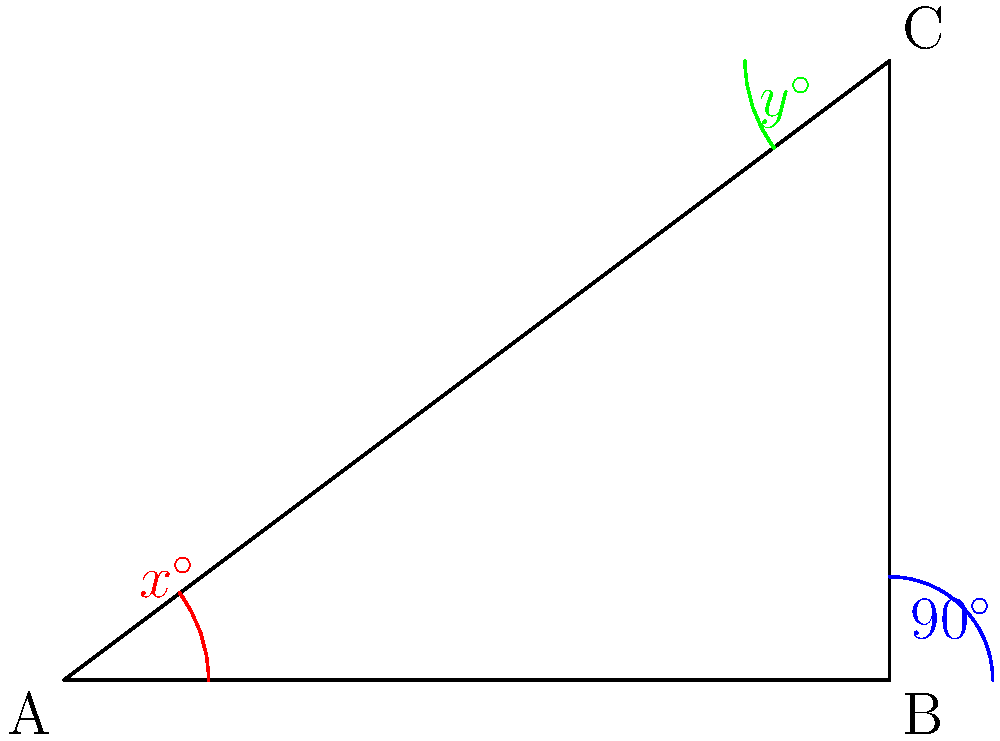In the image above, a right-angled triangle represents the side view of an assistive device used in physical therapy for children. If the angle at B is 90°, and the angles at A and C are represented by x° and y° respectively, what is the value of x + y? Let's approach this step-by-step:

1) In any triangle, the sum of all interior angles is always 180°. This is known as the Triangle Angle Sum Theorem.

2) We are given that the angle at B is 90°. Let's call the angles at A and C as x° and y° respectively.

3) According to the Triangle Angle Sum Theorem:
   $x° + 90° + y° = 180°$

4) We need to find x + y. Let's isolate these terms:
   $x° + y° = 180° - 90°$
   $x° + y° = 90°$

5) Therefore, the sum of x and y is 90°.

This concept is often used in designing assistive devices, where understanding angles is crucial for proper support and function.
Answer: 90° 